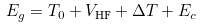Convert formula to latex. <formula><loc_0><loc_0><loc_500><loc_500>E _ { g } = T _ { 0 } + V _ { \text {HF} } + \Delta T + E _ { c }</formula> 